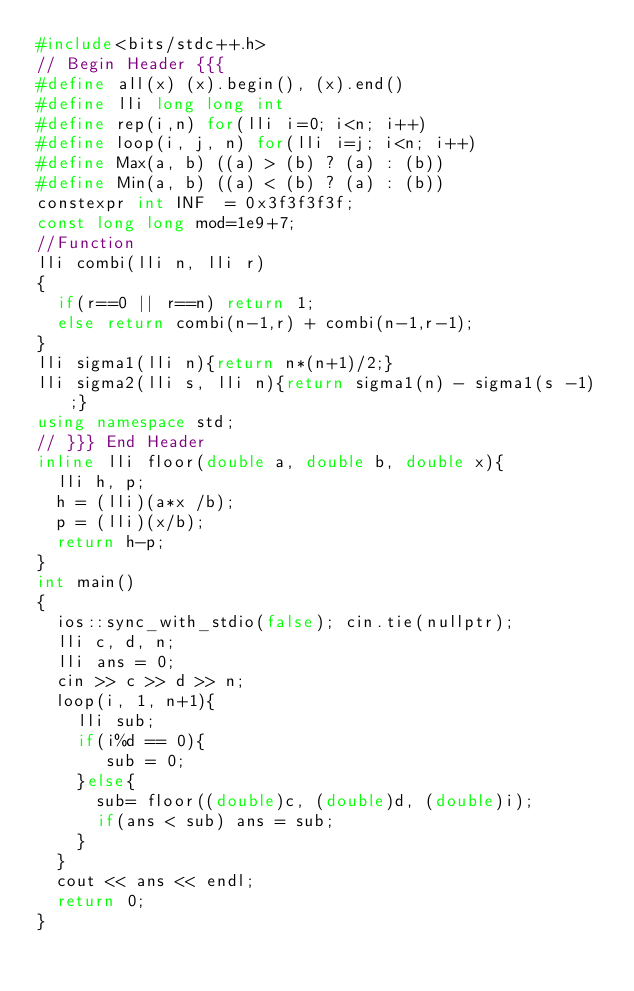Convert code to text. <code><loc_0><loc_0><loc_500><loc_500><_C++_>#include<bits/stdc++.h>
// Begin Header {{{
#define all(x) (x).begin(), (x).end()
#define lli long long int
#define rep(i,n) for(lli i=0; i<n; i++)
#define loop(i, j, n) for(lli i=j; i<n; i++)
#define Max(a, b) ((a) > (b) ? (a) : (b))
#define Min(a, b) ((a) < (b) ? (a) : (b))
constexpr int INF  = 0x3f3f3f3f;
const long long mod=1e9+7;
//Function
lli combi(lli n, lli r)
{
	if(r==0 || r==n) return 1;
	else return combi(n-1,r) + combi(n-1,r-1);
}
lli sigma1(lli n){return n*(n+1)/2;}
lli sigma2(lli s, lli n){return sigma1(n) - sigma1(s -1);}
using namespace std;
// }}} End Header
inline lli floor(double a, double b, double x){
	lli h, p;
	h = (lli)(a*x /b);
	p = (lli)(x/b);
	return h-p;
}
int main()
{
	ios::sync_with_stdio(false); cin.tie(nullptr);
	lli c, d, n;
	lli ans = 0;
	cin >> c >> d >> n;
	loop(i, 1, n+1){
		lli sub;
		if(i%d == 0){
			 sub = 0;
		}else{
			sub= floor((double)c, (double)d, (double)i);
			if(ans < sub) ans = sub;
		}
	}
	cout << ans << endl;
	return 0;
}</code> 